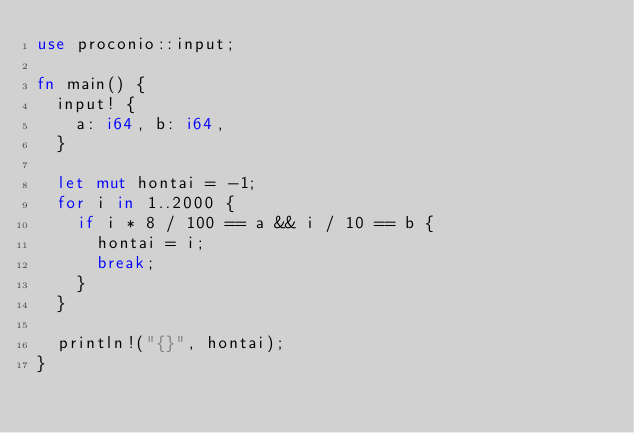Convert code to text. <code><loc_0><loc_0><loc_500><loc_500><_Rust_>use proconio::input;

fn main() {
  input! {
    a: i64, b: i64,
  }
  
  let mut hontai = -1;
  for i in 1..2000 {
    if i * 8 / 100 == a && i / 10 == b {
      hontai = i;
      break;
    }
  }
  
  println!("{}", hontai);
}</code> 